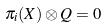<formula> <loc_0><loc_0><loc_500><loc_500>\pi _ { i } ( X ) \otimes Q = 0</formula> 